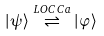<formula> <loc_0><loc_0><loc_500><loc_500>\left | \psi \right \rangle \stackrel { L O C C a } { \rightleftharpoons } \left | \varphi \right \rangle</formula> 